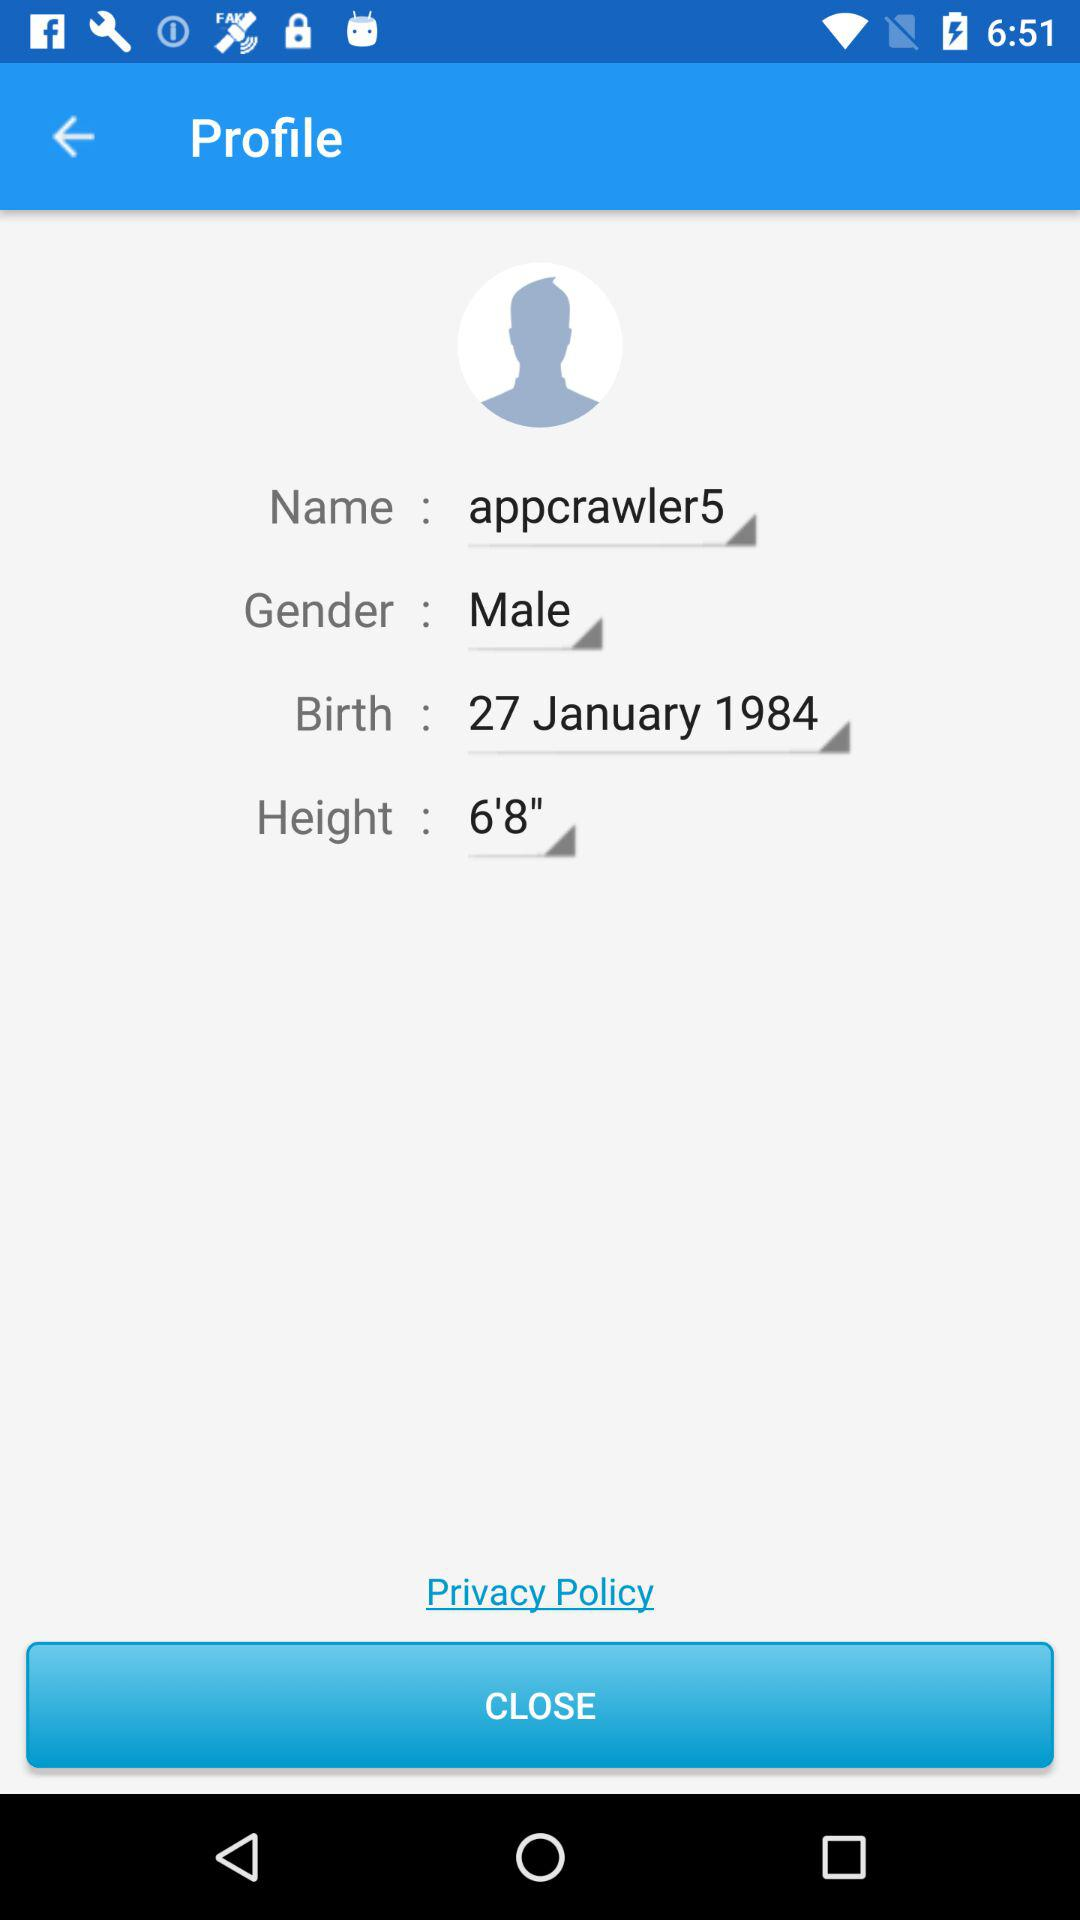What is the height? The height is 6'8". 